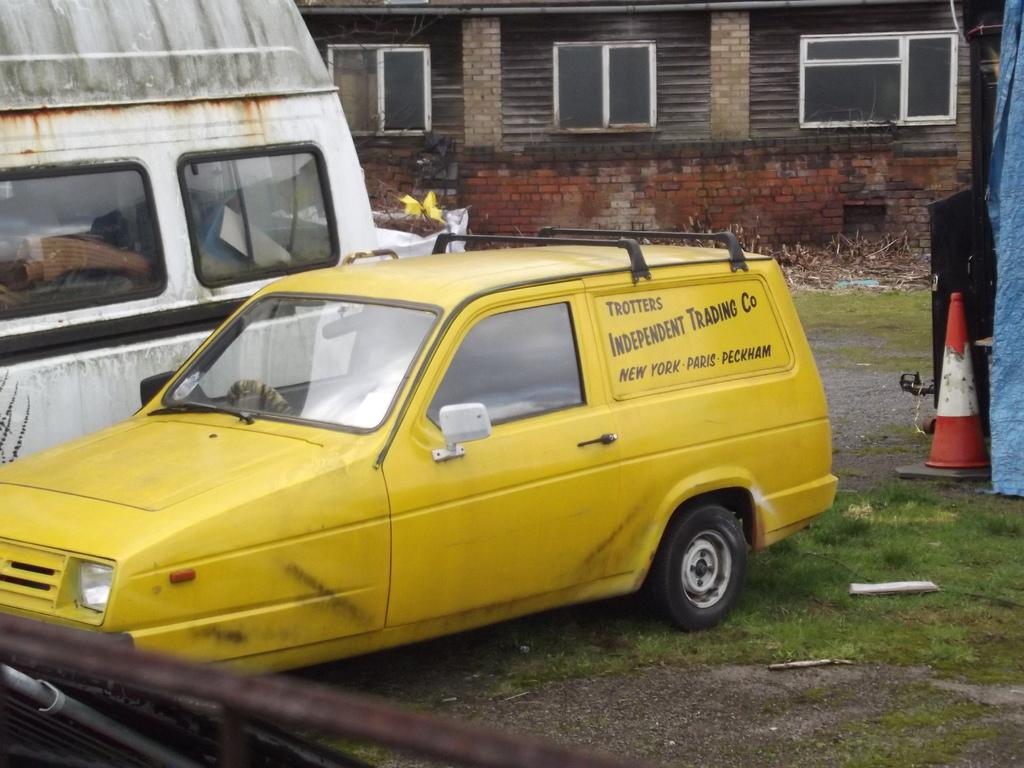<image>
Present a compact description of the photo's key features. A yellow station wagon is parked in a yard and says Trotters Independent Trading Co. 